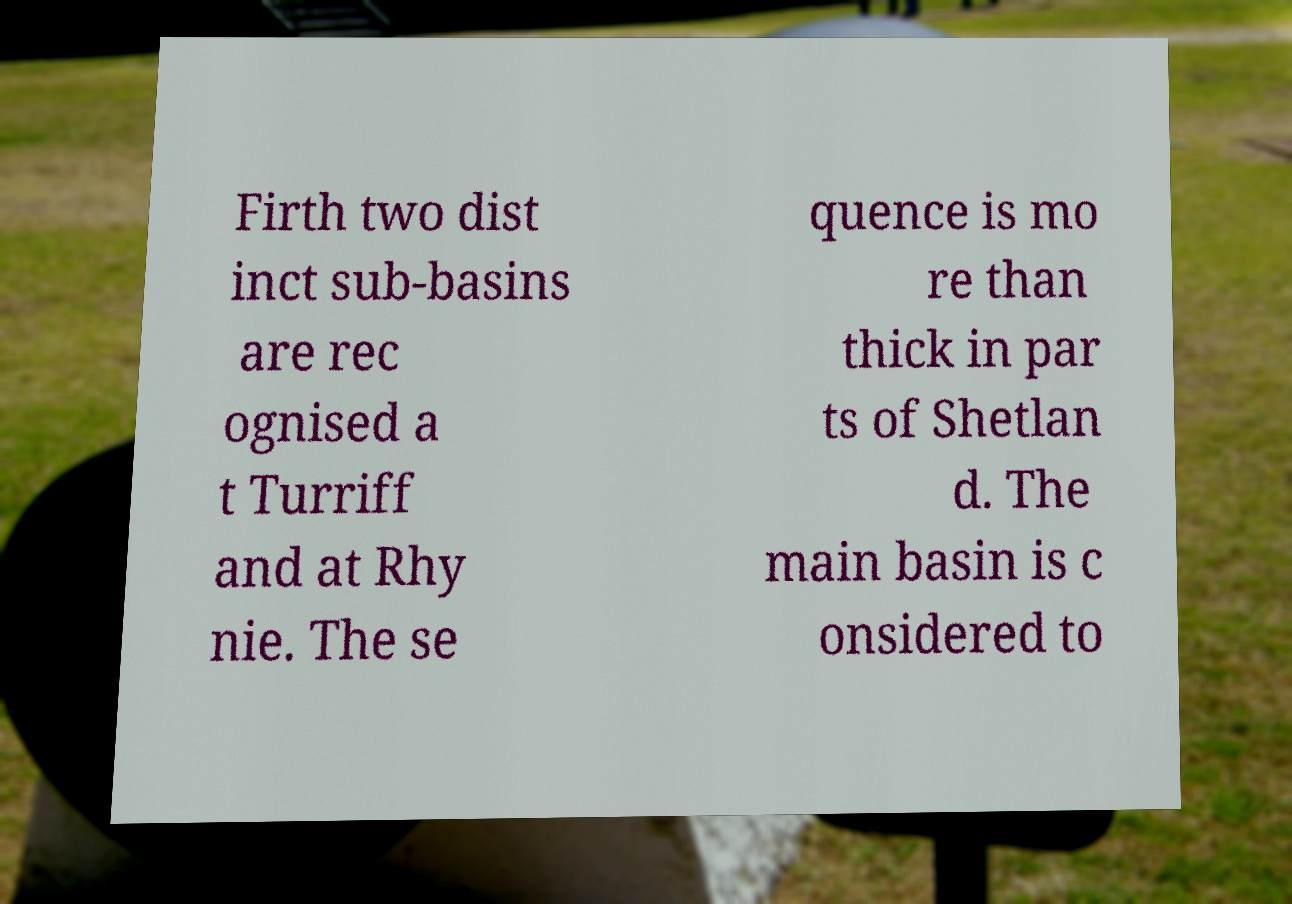For documentation purposes, I need the text within this image transcribed. Could you provide that? Firth two dist inct sub-basins are rec ognised a t Turriff and at Rhy nie. The se quence is mo re than thick in par ts of Shetlan d. The main basin is c onsidered to 